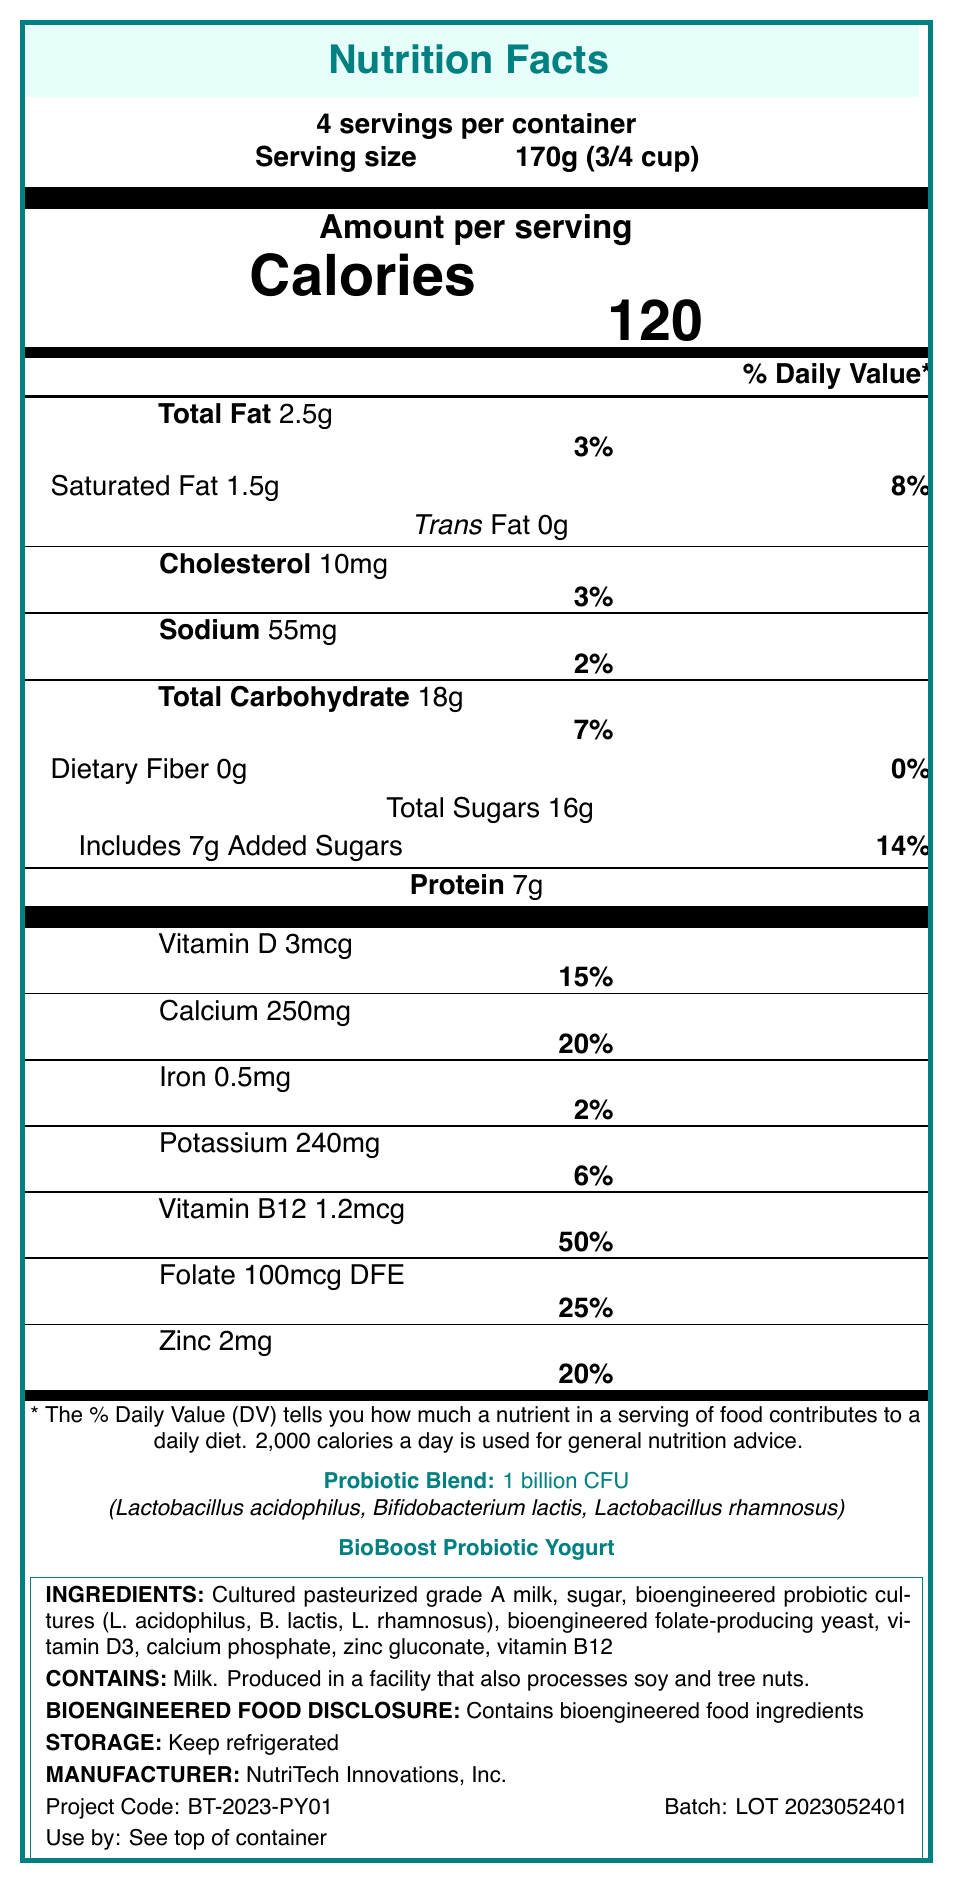What is the serving size of the BioBoost Probiotic Yogurt? The serving size is provided at the top of the document under "Serving size."
Answer: 170g (3/4 cup) How many servings per container does the BioBoost Probiotic Yogurt have? The document states "4 servings per container" near the top.
Answer: 4 What is the total calorie count per serving? The amount per serving shows "Calories 120."
Answer: 120 What are the main probiotic strains included in the BioBoost Probiotic Yogurt? These strains are listed under the "Probiotic Blend" section.
Answer: Lactobacillus acidophilus, Bifidobacterium lactis, Lactobacillus rhamnosus What percentage of Vitamin B12 is provided in one serving based on the daily value? The percentage daily value for Vitamin B12 is given as 50%.
Answer: 50% What amount of total sugars is present in one serving of the yogurt? A. 10g B. 12g C. 14g D. 16g "Total Sugars 16g" is listed under the carbohydrate section.
Answer: D. 16g Which of the following nutrients has the highest daily value percentage per serving? i. Vitamin D ii. Calcium iii. Folate iv. Zinc Calcium has a 20% daily value, which is the highest among the provided options.
Answer: ii. Calcium Is the BioBoost Probiotic Yogurt bioengineered? The document contains the "Bioengineered food disclosure" noting that it contains bioengineered food ingredients.
Answer: Yes Does the product contain any allergens, and if so, which ones? The allergen information states "Contains milk."
Answer: Yes, milk Summarize the main idea of the Nutrition Facts Label for the BioBoost Probiotic Yogurt. The summary covers all the main sections presented in the document, including nutritional values, added probiotics, allergens, storage, and manufacturing details.
Answer: The Nutrition Facts Label for BioBoost Probiotic Yogurt provides detailed nutritional information per 170g serving, outlining calories, fats, cholesterol, sodium, carbohydrates, proteins, vitamins, minerals, and probiotic strains. The yogurt contains enhanced micronutrients and bioengineered food ingredients and includes an allergen statement for milk. It also provides storage instructions and manufacturer details. Can the production date of the BioBoost Probiotic Yogurt be determined from the document? The document provides a batch number and expiration date location but does not specify the production date.
Answer: Not enough information What is the amount of calcium per serving? The amount of calcium is listed as "Calcium 250mg" with a 20% daily value.
Answer: 250mg Which manufacturing regulatory compliance measures are mentioned in the document? A. FDA registration B. ISO certification C. HACCP plan D. GMP certification The document mentions FDA registration, HACCP plan, and GMP certification but not ISO certification.
Answer: A, C, and D 